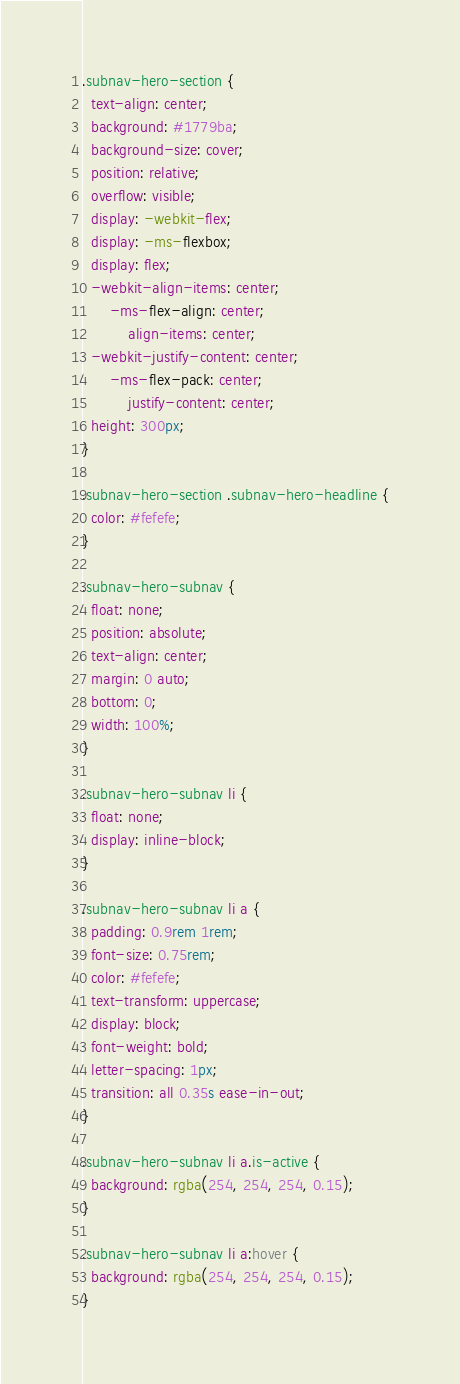Convert code to text. <code><loc_0><loc_0><loc_500><loc_500><_CSS_>.subnav-hero-section {
  text-align: center;
  background: #1779ba;
  background-size: cover;
  position: relative;
  overflow: visible;
  display: -webkit-flex;
  display: -ms-flexbox;
  display: flex;
  -webkit-align-items: center;
      -ms-flex-align: center;
          align-items: center;
  -webkit-justify-content: center;
      -ms-flex-pack: center;
          justify-content: center;
  height: 300px;
}

.subnav-hero-section .subnav-hero-headline {
  color: #fefefe;
}

.subnav-hero-subnav {
  float: none;
  position: absolute;
  text-align: center;
  margin: 0 auto;
  bottom: 0;
  width: 100%;
}

.subnav-hero-subnav li {
  float: none;
  display: inline-block;
}

.subnav-hero-subnav li a {
  padding: 0.9rem 1rem;
  font-size: 0.75rem;
  color: #fefefe;
  text-transform: uppercase;
  display: block;
  font-weight: bold;
  letter-spacing: 1px;
  transition: all 0.35s ease-in-out;
}

.subnav-hero-subnav li a.is-active {
  background: rgba(254, 254, 254, 0.15);
}

.subnav-hero-subnav li a:hover {
  background: rgba(254, 254, 254, 0.15);
}</code> 